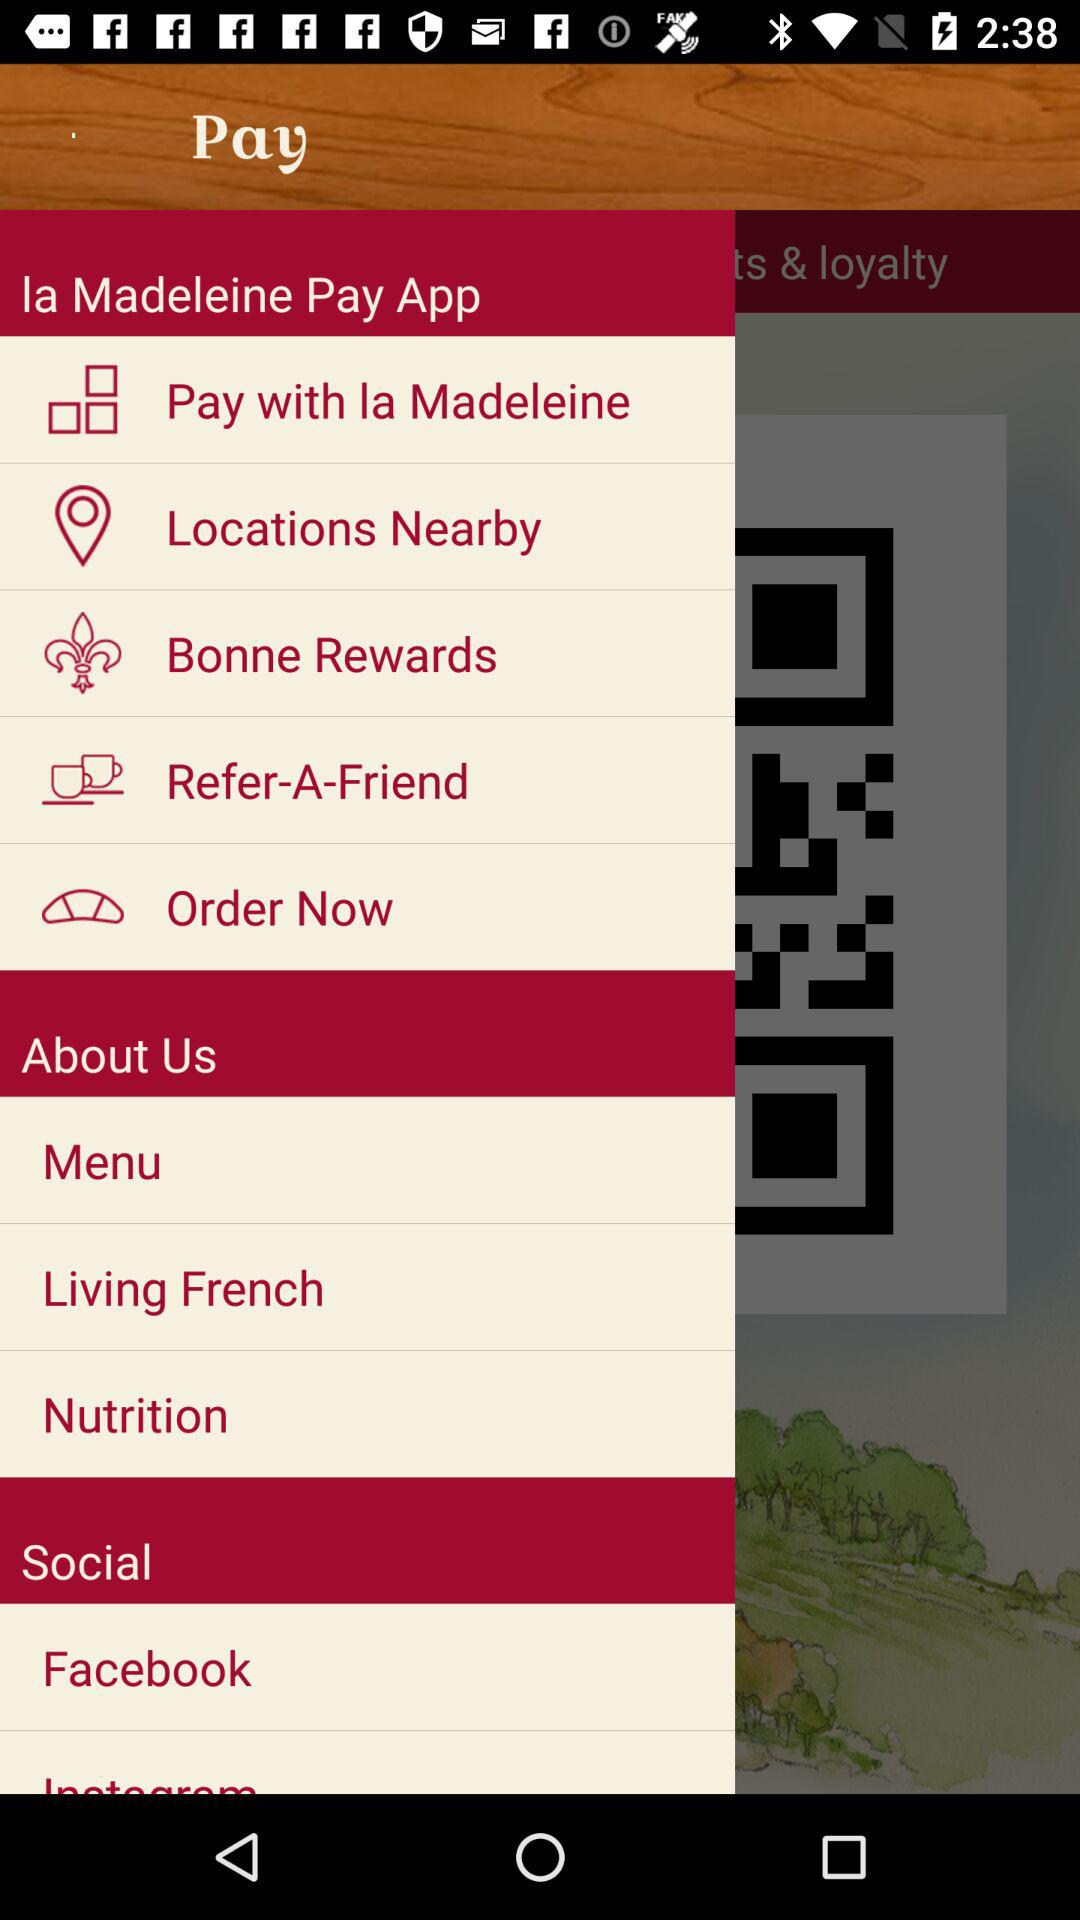What is the name of the application? The name of the application is "la Madeleine Pay App". 